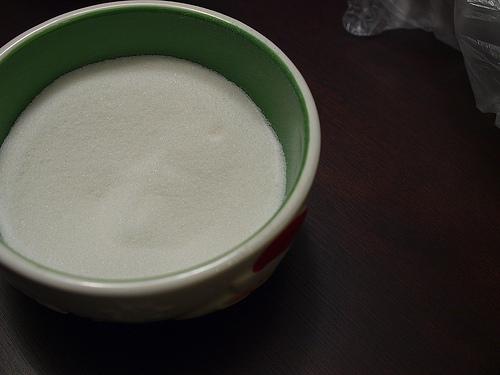<image>
Can you confirm if the table is under the bowl? Yes. The table is positioned underneath the bowl, with the bowl above it in the vertical space. Is the sugar in the bowl? Yes. The sugar is contained within or inside the bowl, showing a containment relationship. 